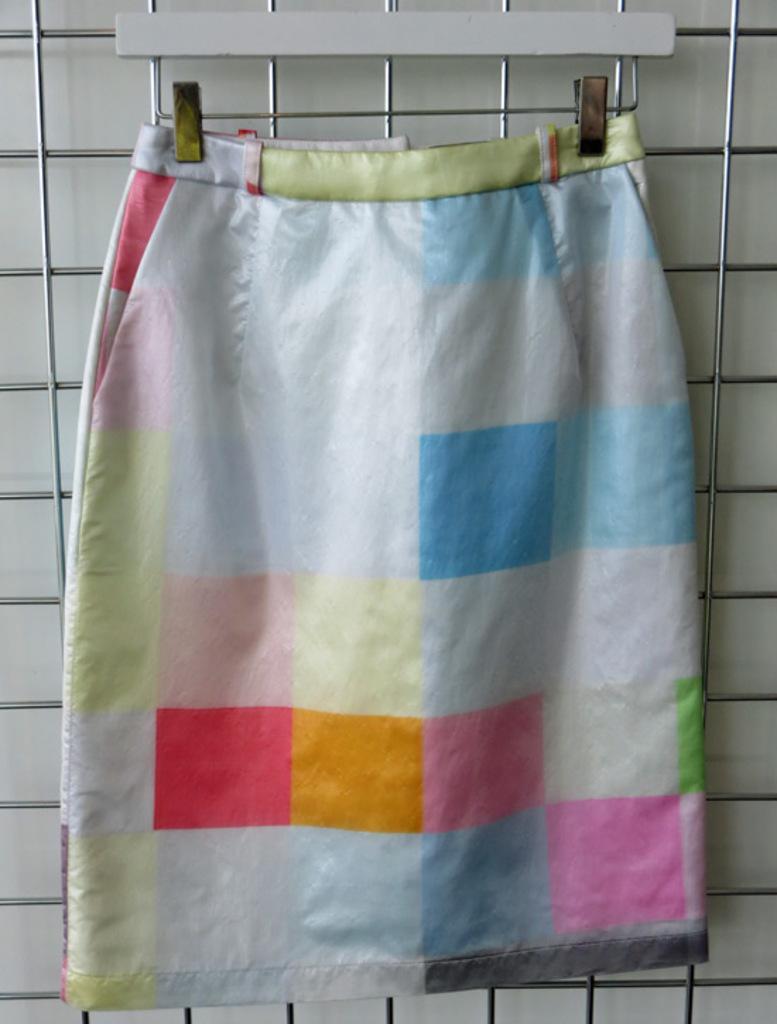Please provide a concise description of this image. In this image there is a skirt on the grill. 